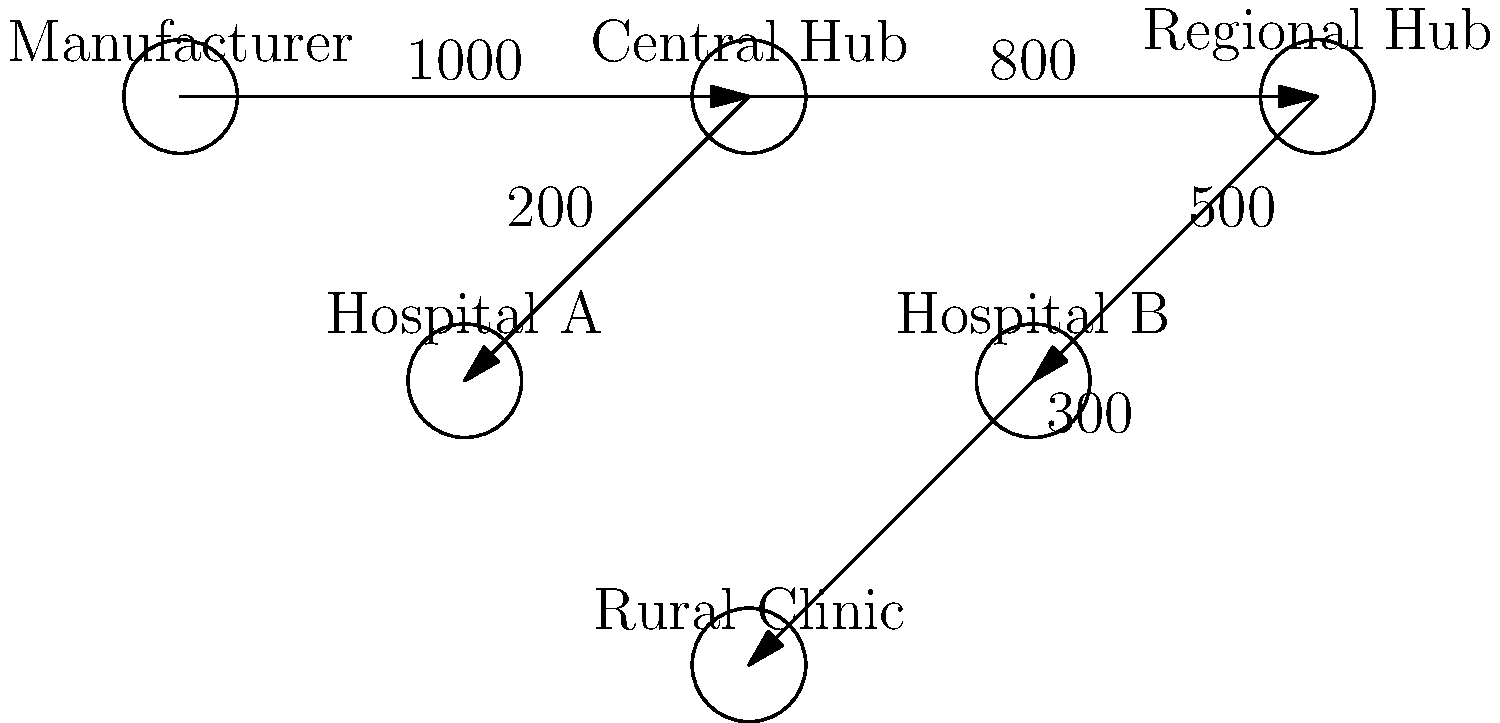Based on the vaccine distribution network shown in the diagram, what is the maximum number of vaccine doses that can reach the Rural Clinic, assuming no losses in transit? To determine the maximum number of vaccine doses that can reach the Rural Clinic, we need to analyze the flow of vaccines through the distribution network:

1. The Manufacturer produces 1000 doses, which are sent to the Central Hub.
2. From the Central Hub:
   a. 200 doses are sent to Hospital A
   b. 800 doses continue to the Regional Hub
3. From the Regional Hub:
   a. 500 doses are sent to Hospital B
   b. 300 doses are sent to the Rural Clinic

The question asks specifically about the Rural Clinic, which receives 300 doses from the Regional Hub. This is the maximum number of doses that can reach the Rural Clinic based on the given network, assuming no losses in transit.

The flow of vaccines to other locations (Hospital A and Hospital B) does not affect the number of doses reaching the Rural Clinic in this scenario.
Answer: 300 doses 